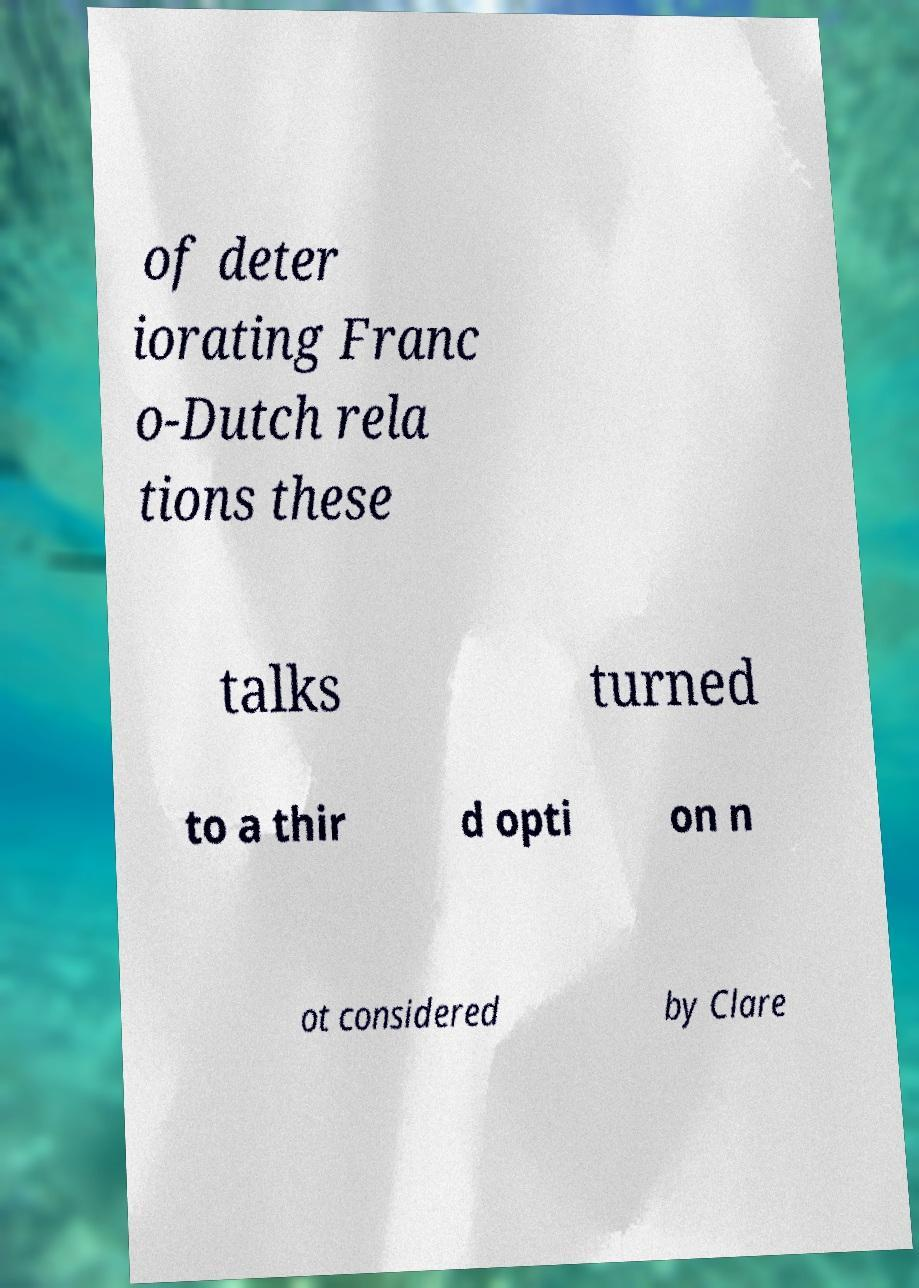What messages or text are displayed in this image? I need them in a readable, typed format. of deter iorating Franc o-Dutch rela tions these talks turned to a thir d opti on n ot considered by Clare 